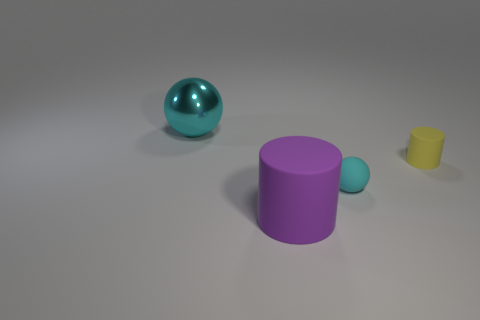Subtract all gray spheres. Subtract all green cylinders. How many spheres are left? 2 Add 4 large objects. How many objects exist? 8 Subtract 0 gray cubes. How many objects are left? 4 Subtract all large purple cylinders. Subtract all cyan metallic objects. How many objects are left? 2 Add 4 cyan objects. How many cyan objects are left? 6 Add 2 shiny objects. How many shiny objects exist? 3 